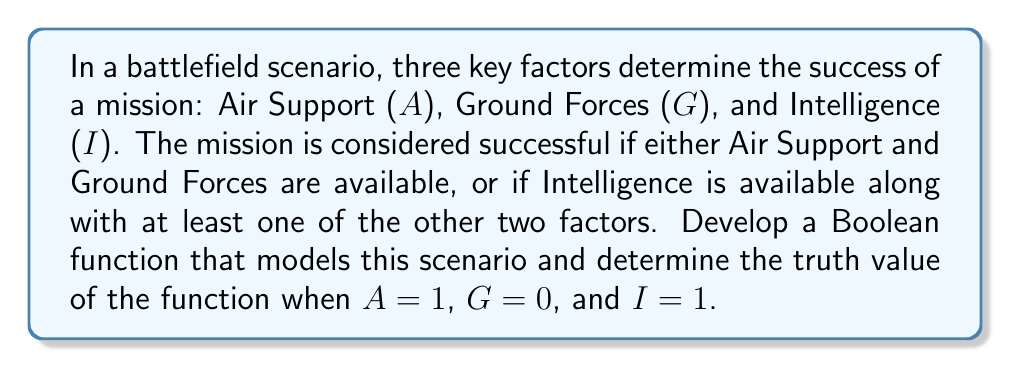What is the answer to this math problem? To develop the Boolean function for this scenario, we need to translate the given conditions into logical operations:

1. Success condition 1: Air Support AND Ground Forces
   $A \land G$

2. Success condition 2: Intelligence AND (Air Support OR Ground Forces)
   $I \land (A \lor G)$

3. The overall success is achieved if either of these conditions is met, so we combine them with OR:
   $f(A,G,I) = (A \land G) \lor (I \land (A \lor G))$

Now, let's evaluate the function with the given values: A = 1, G = 0, and I = 1

Step 1: Evaluate $A \land G$
$1 \land 0 = 0$

Step 2: Evaluate $A \lor G$
$1 \lor 0 = 1$

Step 3: Evaluate $I \land (A \lor G)$
$1 \land 1 = 1$

Step 4: Combine the results using OR
$f(1,0,1) = 0 \lor 1 = 1$

Therefore, the Boolean function evaluates to 1 (true) for the given input values.
Answer: $f(A,G,I) = (A \land G) \lor (I \land (A \lor G)) = 1$ 